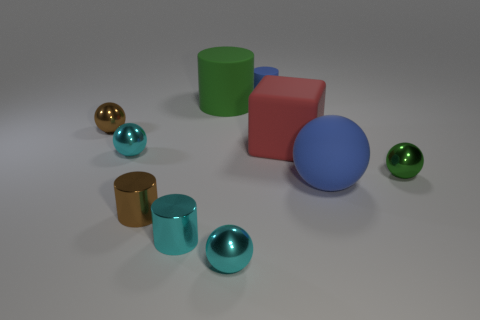Subtract all green balls. How many balls are left? 4 Subtract all blue spheres. How many spheres are left? 4 Subtract all yellow balls. Subtract all blue cubes. How many balls are left? 5 Subtract all cylinders. How many objects are left? 6 Subtract 1 red cubes. How many objects are left? 9 Subtract all large gray shiny cylinders. Subtract all blue things. How many objects are left? 8 Add 9 tiny green metal spheres. How many tiny green metal spheres are left? 10 Add 7 tiny gray rubber cylinders. How many tiny gray rubber cylinders exist? 7 